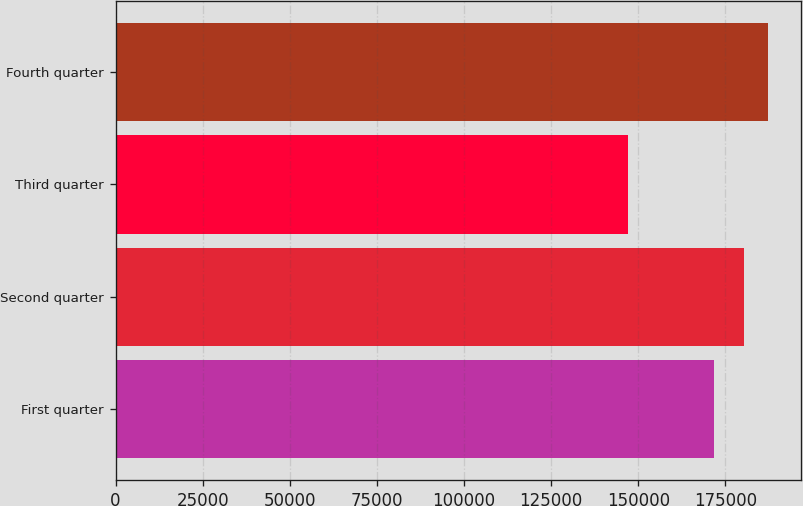Convert chart to OTSL. <chart><loc_0><loc_0><loc_500><loc_500><bar_chart><fcel>First quarter<fcel>Second quarter<fcel>Third quarter<fcel>Fourth quarter<nl><fcel>171718<fcel>180201<fcel>146938<fcel>187231<nl></chart> 